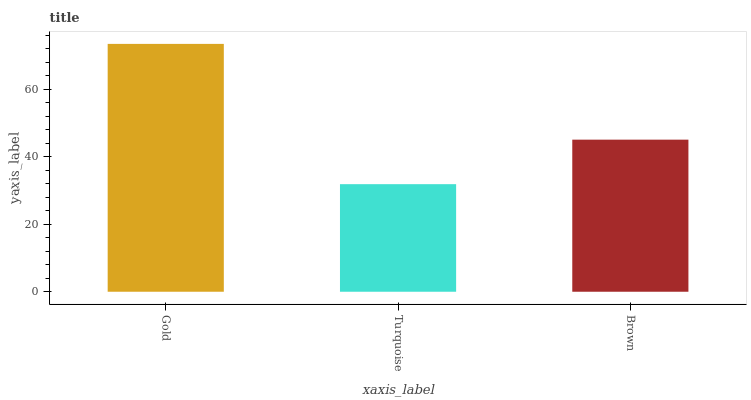Is Brown the minimum?
Answer yes or no. No. Is Brown the maximum?
Answer yes or no. No. Is Brown greater than Turquoise?
Answer yes or no. Yes. Is Turquoise less than Brown?
Answer yes or no. Yes. Is Turquoise greater than Brown?
Answer yes or no. No. Is Brown less than Turquoise?
Answer yes or no. No. Is Brown the high median?
Answer yes or no. Yes. Is Brown the low median?
Answer yes or no. Yes. Is Gold the high median?
Answer yes or no. No. Is Turquoise the low median?
Answer yes or no. No. 